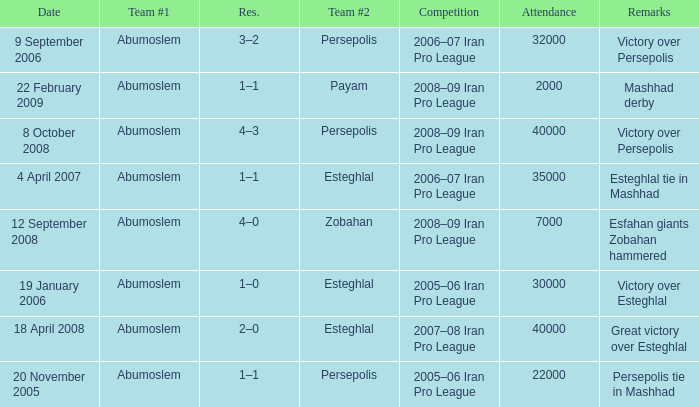What was the largest attendance? 40000.0. Parse the table in full. {'header': ['Date', 'Team #1', 'Res.', 'Team #2', 'Competition', 'Attendance', 'Remarks'], 'rows': [['9 September 2006', 'Abumoslem', '3–2', 'Persepolis', '2006–07 Iran Pro League', '32000', 'Victory over Persepolis'], ['22 February 2009', 'Abumoslem', '1–1', 'Payam', '2008–09 Iran Pro League', '2000', 'Mashhad derby'], ['8 October 2008', 'Abumoslem', '4–3', 'Persepolis', '2008–09 Iran Pro League', '40000', 'Victory over Persepolis'], ['4 April 2007', 'Abumoslem', '1–1', 'Esteghlal', '2006–07 Iran Pro League', '35000', 'Esteghlal tie in Mashhad'], ['12 September 2008', 'Abumoslem', '4–0', 'Zobahan', '2008–09 Iran Pro League', '7000', 'Esfahan giants Zobahan hammered'], ['19 January 2006', 'Abumoslem', '1–0', 'Esteghlal', '2005–06 Iran Pro League', '30000', 'Victory over Esteghlal'], ['18 April 2008', 'Abumoslem', '2–0', 'Esteghlal', '2007–08 Iran Pro League', '40000', 'Great victory over Esteghlal'], ['20 November 2005', 'Abumoslem', '1–1', 'Persepolis', '2005–06 Iran Pro League', '22000', 'Persepolis tie in Mashhad']]} 